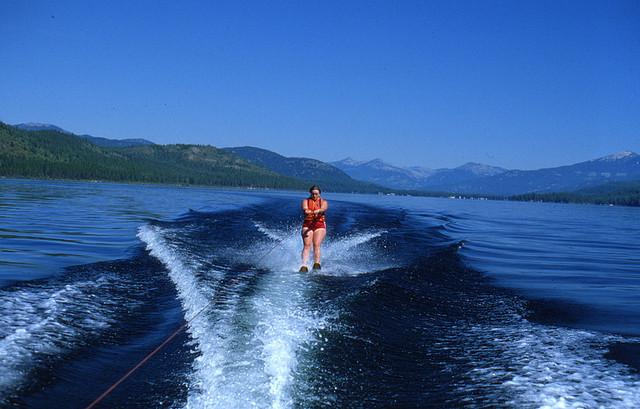What is condition of sky?
Quick response, please. Clear. What color is most of the photo?
Quick response, please. Blue. What is the person wearing?
Answer briefly. Life vest. 